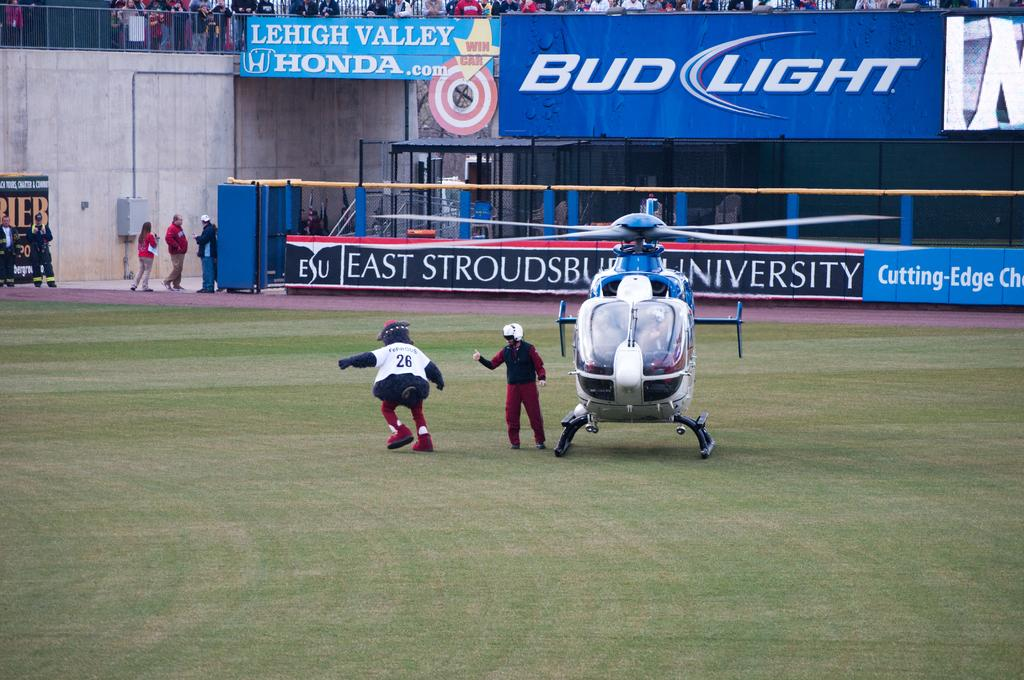Provide a one-sentence caption for the provided image. Mascot wearing the jersey number 26 walking on the grass. 